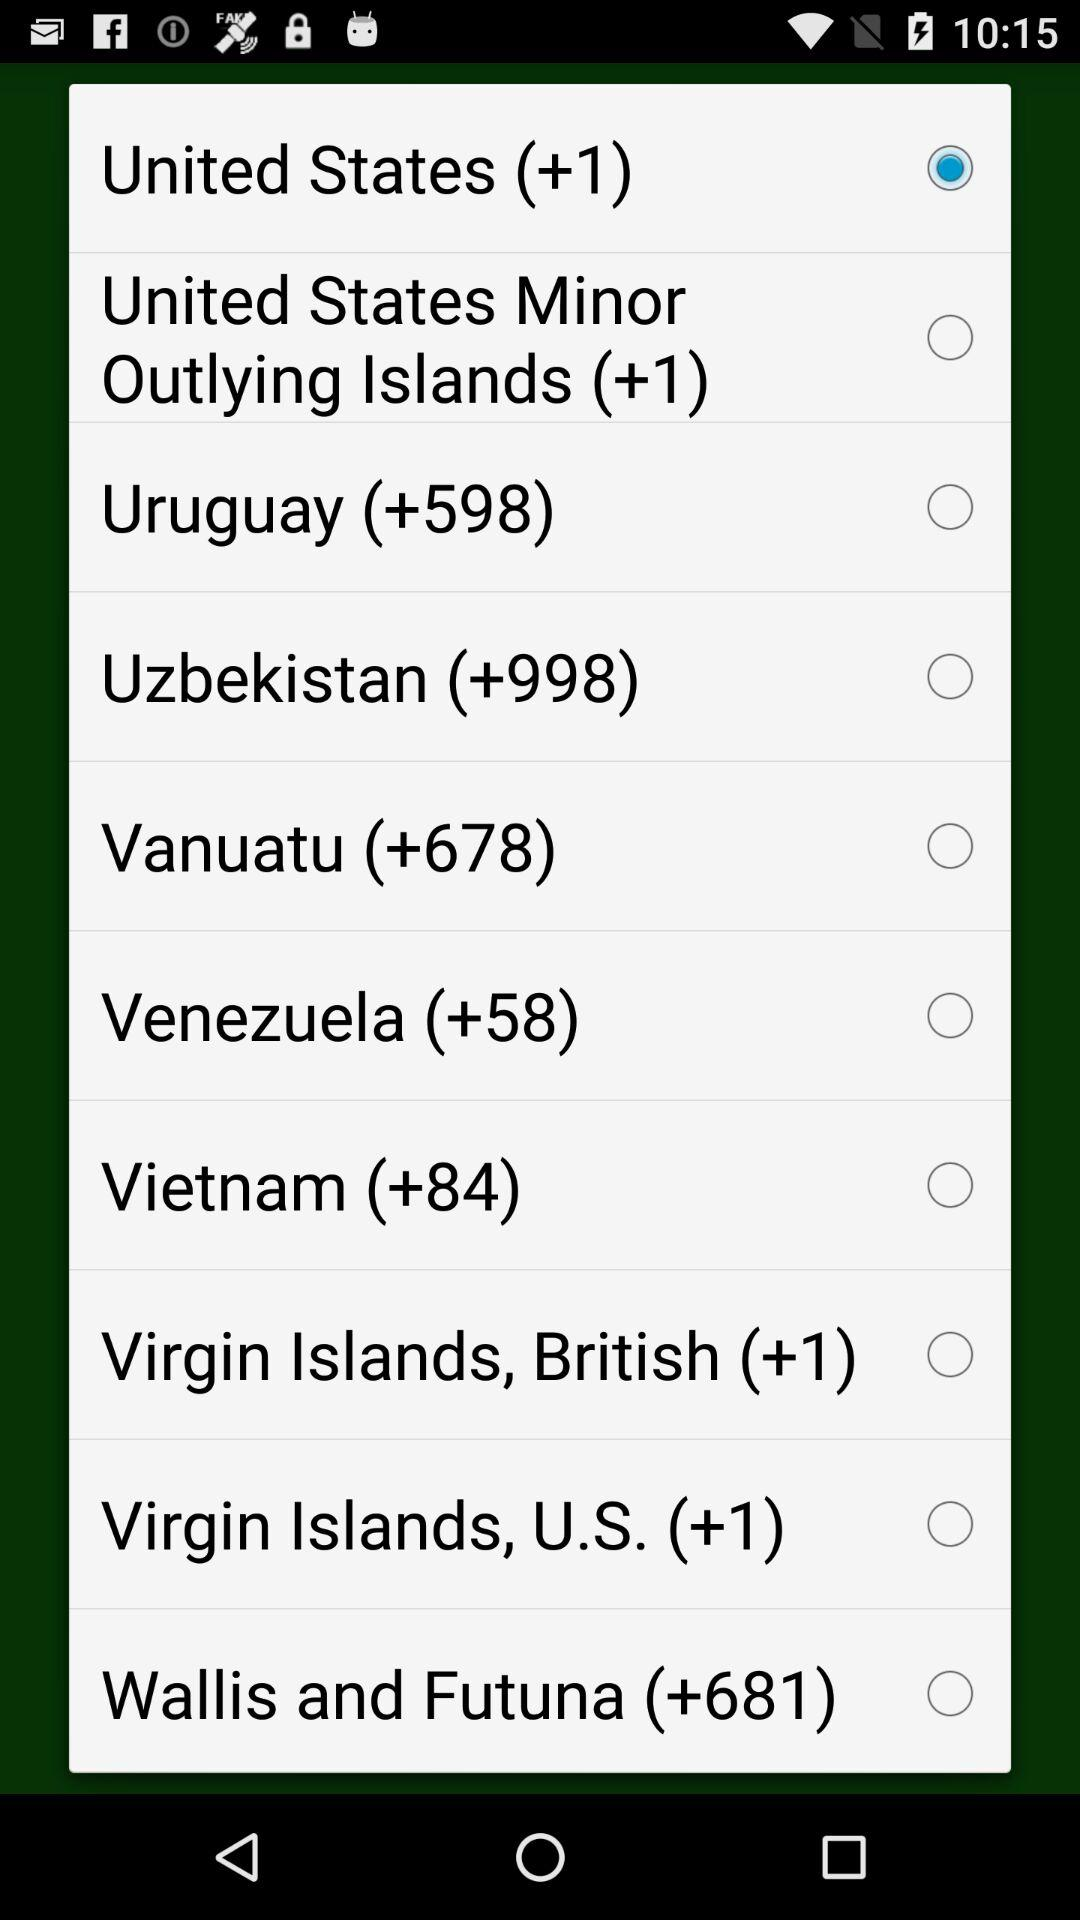What is the code of Vanuatu? The code is +678. 